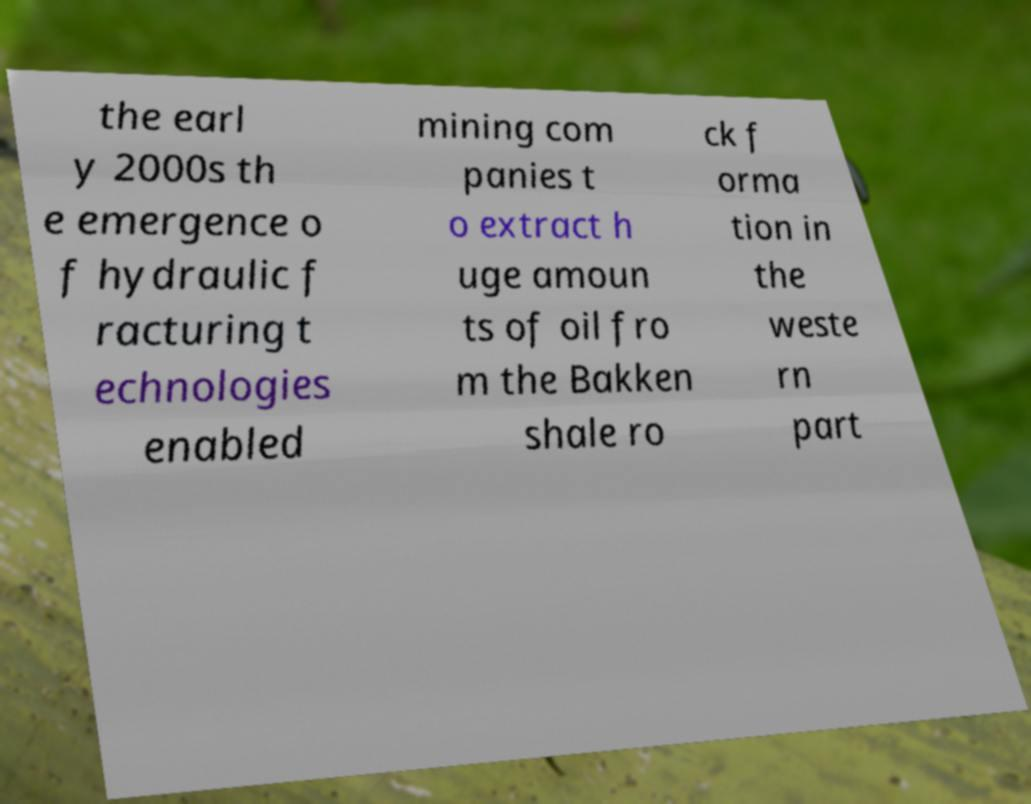I need the written content from this picture converted into text. Can you do that? the earl y 2000s th e emergence o f hydraulic f racturing t echnologies enabled mining com panies t o extract h uge amoun ts of oil fro m the Bakken shale ro ck f orma tion in the weste rn part 